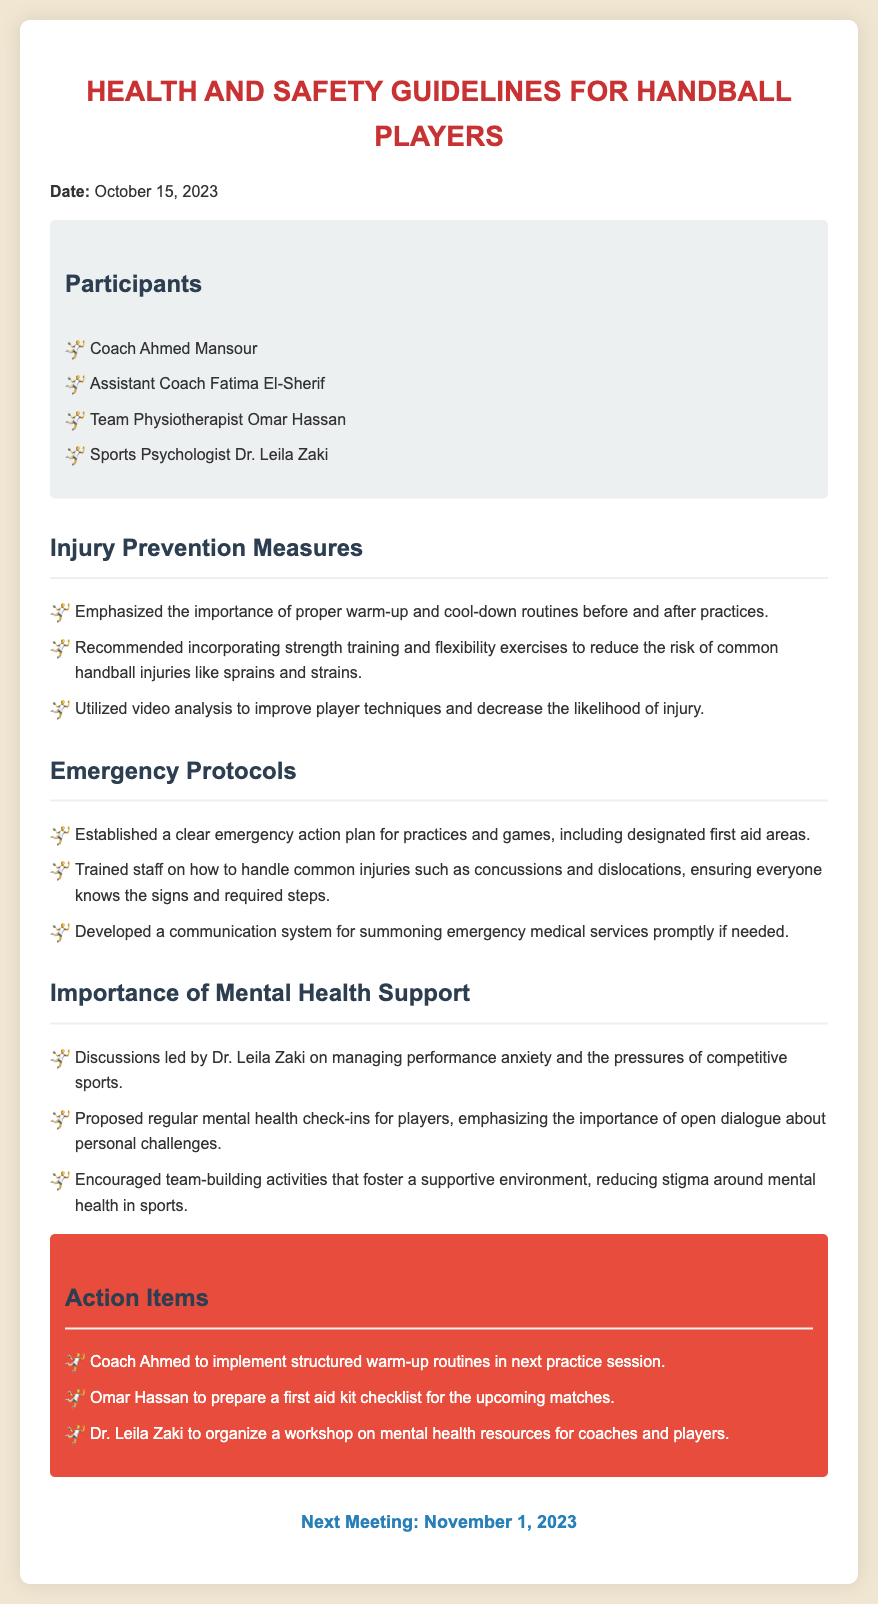what is the date of the meeting? The date of the meeting is explicitly stated in the introduction of the document.
Answer: October 15, 2023 who is the team physiotherapist? The document lists participants and their roles, including the physiotherapist.
Answer: Omar Hassan what are the emergency protocols established? The emergency protocols are highlighted in their respective section, detailing the actions and preparedness measures.
Answer: A clear emergency action plan how many action items are listed? The document contains a specific section detailing all action items that need to be addressed after the meeting.
Answer: Three who led the discussions on mental health support? The document indicates who led the discussions in the section regarding mental health support.
Answer: Dr. Leila Zaki what is one recommended injury prevention measure? The injury prevention measures section includes specific recommendations to protect players.
Answer: Proper warm-up and cool-down routines when is the next meeting scheduled? The document clearly mentions the date for the next scheduled meeting at the end.
Answer: November 1, 2023 what is the purpose of incorporating strength training? The document explains the intent behind including certain exercises within the injury prevention measures.
Answer: To reduce the risk of common handball injuries 